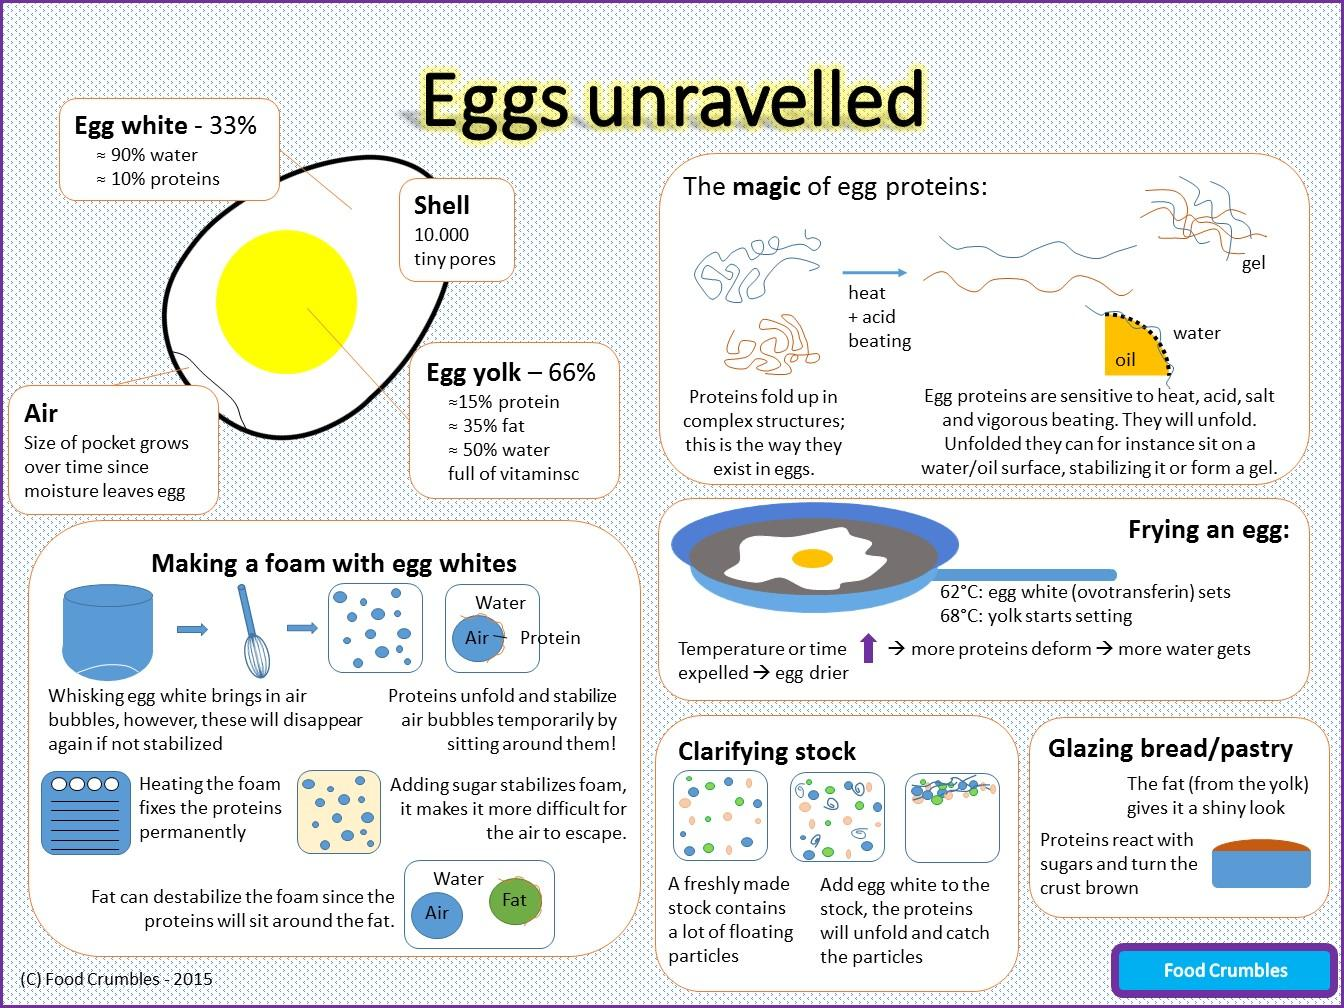Highlight a few significant elements in this photo. When cooking an egg, the egg white sets faster than the yolk. The addition of fat to foam can destabilize it, causing it to become less stable and more prone to collapse. When frying an egg, the yolk is slower to set than the white. The egg white contains more water than the egg yolk. According to research, approximately 90% of an egg white is composed of water. 